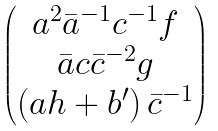<formula> <loc_0><loc_0><loc_500><loc_500>\begin{pmatrix} a ^ { 2 } \bar { a } ^ { - 1 } c ^ { - 1 } f \\ \bar { a } c \bar { c } ^ { - 2 } g \\ \left ( a h + b ^ { \prime } \right ) \bar { c } ^ { - 1 } \end{pmatrix}</formula> 